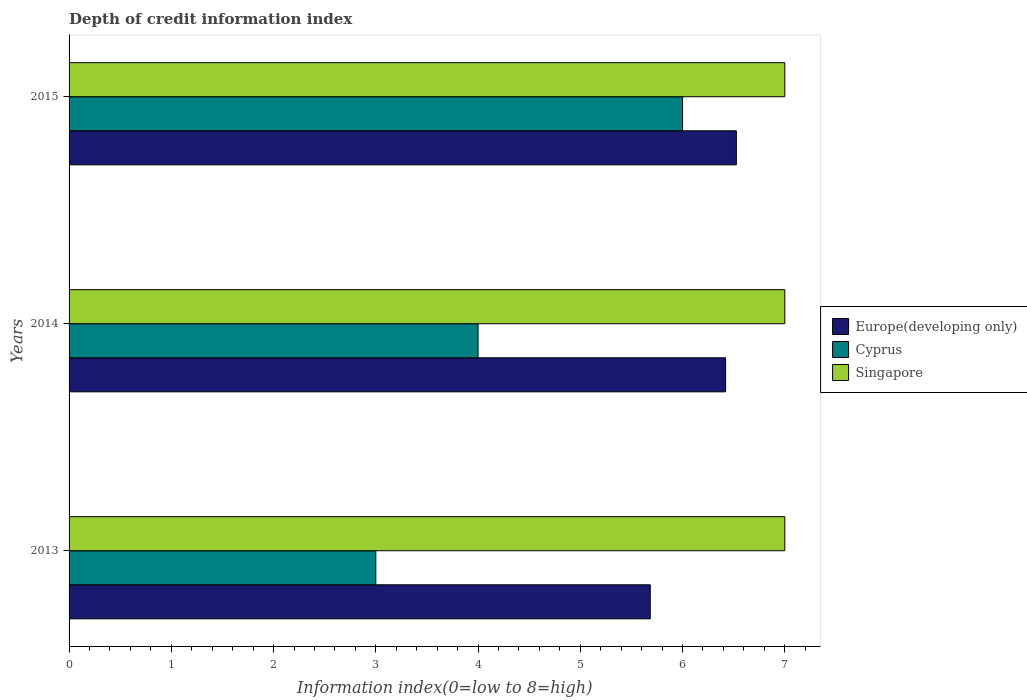How many different coloured bars are there?
Your answer should be compact. 3. Are the number of bars per tick equal to the number of legend labels?
Your response must be concise. Yes. How many bars are there on the 2nd tick from the bottom?
Your response must be concise. 3. What is the label of the 2nd group of bars from the top?
Ensure brevity in your answer.  2014. What is the information index in Cyprus in 2014?
Make the answer very short. 4. Across all years, what is the maximum information index in Cyprus?
Ensure brevity in your answer.  6. Across all years, what is the minimum information index in Europe(developing only)?
Offer a terse response. 5.68. In which year was the information index in Europe(developing only) maximum?
Offer a very short reply. 2015. In which year was the information index in Singapore minimum?
Make the answer very short. 2013. What is the total information index in Singapore in the graph?
Offer a terse response. 21. What is the difference between the information index in Europe(developing only) in 2014 and that in 2015?
Ensure brevity in your answer.  -0.11. What is the difference between the information index in Cyprus in 2014 and the information index in Europe(developing only) in 2013?
Ensure brevity in your answer.  -1.68. In the year 2015, what is the difference between the information index in Cyprus and information index in Europe(developing only)?
Ensure brevity in your answer.  -0.53. What is the ratio of the information index in Europe(developing only) in 2014 to that in 2015?
Your response must be concise. 0.98. What is the difference between the highest and the second highest information index in Europe(developing only)?
Your answer should be very brief. 0.11. What is the difference between the highest and the lowest information index in Europe(developing only)?
Provide a short and direct response. 0.84. What does the 3rd bar from the top in 2015 represents?
Provide a succinct answer. Europe(developing only). What does the 2nd bar from the bottom in 2015 represents?
Give a very brief answer. Cyprus. How many bars are there?
Provide a succinct answer. 9. Are all the bars in the graph horizontal?
Your answer should be very brief. Yes. Does the graph contain any zero values?
Provide a succinct answer. No. Does the graph contain grids?
Your answer should be very brief. No. How are the legend labels stacked?
Your answer should be very brief. Vertical. What is the title of the graph?
Offer a very short reply. Depth of credit information index. Does "Guinea" appear as one of the legend labels in the graph?
Your response must be concise. No. What is the label or title of the X-axis?
Your response must be concise. Information index(0=low to 8=high). What is the label or title of the Y-axis?
Provide a succinct answer. Years. What is the Information index(0=low to 8=high) in Europe(developing only) in 2013?
Offer a terse response. 5.68. What is the Information index(0=low to 8=high) in Singapore in 2013?
Give a very brief answer. 7. What is the Information index(0=low to 8=high) of Europe(developing only) in 2014?
Ensure brevity in your answer.  6.42. What is the Information index(0=low to 8=high) in Cyprus in 2014?
Offer a terse response. 4. What is the Information index(0=low to 8=high) of Europe(developing only) in 2015?
Your answer should be compact. 6.53. What is the Information index(0=low to 8=high) in Singapore in 2015?
Your answer should be compact. 7. Across all years, what is the maximum Information index(0=low to 8=high) of Europe(developing only)?
Offer a very short reply. 6.53. Across all years, what is the minimum Information index(0=low to 8=high) in Europe(developing only)?
Provide a succinct answer. 5.68. What is the total Information index(0=low to 8=high) of Europe(developing only) in the graph?
Give a very brief answer. 18.63. What is the total Information index(0=low to 8=high) in Singapore in the graph?
Ensure brevity in your answer.  21. What is the difference between the Information index(0=low to 8=high) in Europe(developing only) in 2013 and that in 2014?
Your answer should be very brief. -0.74. What is the difference between the Information index(0=low to 8=high) of Cyprus in 2013 and that in 2014?
Your answer should be very brief. -1. What is the difference between the Information index(0=low to 8=high) of Europe(developing only) in 2013 and that in 2015?
Your answer should be compact. -0.84. What is the difference between the Information index(0=low to 8=high) of Cyprus in 2013 and that in 2015?
Offer a terse response. -3. What is the difference between the Information index(0=low to 8=high) of Europe(developing only) in 2014 and that in 2015?
Provide a succinct answer. -0.11. What is the difference between the Information index(0=low to 8=high) of Cyprus in 2014 and that in 2015?
Keep it short and to the point. -2. What is the difference between the Information index(0=low to 8=high) in Europe(developing only) in 2013 and the Information index(0=low to 8=high) in Cyprus in 2014?
Your response must be concise. 1.68. What is the difference between the Information index(0=low to 8=high) in Europe(developing only) in 2013 and the Information index(0=low to 8=high) in Singapore in 2014?
Your response must be concise. -1.32. What is the difference between the Information index(0=low to 8=high) of Europe(developing only) in 2013 and the Information index(0=low to 8=high) of Cyprus in 2015?
Give a very brief answer. -0.32. What is the difference between the Information index(0=low to 8=high) of Europe(developing only) in 2013 and the Information index(0=low to 8=high) of Singapore in 2015?
Keep it short and to the point. -1.32. What is the difference between the Information index(0=low to 8=high) in Cyprus in 2013 and the Information index(0=low to 8=high) in Singapore in 2015?
Provide a succinct answer. -4. What is the difference between the Information index(0=low to 8=high) in Europe(developing only) in 2014 and the Information index(0=low to 8=high) in Cyprus in 2015?
Offer a very short reply. 0.42. What is the difference between the Information index(0=low to 8=high) in Europe(developing only) in 2014 and the Information index(0=low to 8=high) in Singapore in 2015?
Provide a succinct answer. -0.58. What is the average Information index(0=low to 8=high) of Europe(developing only) per year?
Your response must be concise. 6.21. What is the average Information index(0=low to 8=high) of Cyprus per year?
Offer a very short reply. 4.33. What is the average Information index(0=low to 8=high) of Singapore per year?
Provide a short and direct response. 7. In the year 2013, what is the difference between the Information index(0=low to 8=high) in Europe(developing only) and Information index(0=low to 8=high) in Cyprus?
Your answer should be very brief. 2.68. In the year 2013, what is the difference between the Information index(0=low to 8=high) of Europe(developing only) and Information index(0=low to 8=high) of Singapore?
Provide a short and direct response. -1.32. In the year 2013, what is the difference between the Information index(0=low to 8=high) in Cyprus and Information index(0=low to 8=high) in Singapore?
Keep it short and to the point. -4. In the year 2014, what is the difference between the Information index(0=low to 8=high) in Europe(developing only) and Information index(0=low to 8=high) in Cyprus?
Your answer should be compact. 2.42. In the year 2014, what is the difference between the Information index(0=low to 8=high) of Europe(developing only) and Information index(0=low to 8=high) of Singapore?
Provide a short and direct response. -0.58. In the year 2014, what is the difference between the Information index(0=low to 8=high) in Cyprus and Information index(0=low to 8=high) in Singapore?
Provide a short and direct response. -3. In the year 2015, what is the difference between the Information index(0=low to 8=high) of Europe(developing only) and Information index(0=low to 8=high) of Cyprus?
Provide a short and direct response. 0.53. In the year 2015, what is the difference between the Information index(0=low to 8=high) of Europe(developing only) and Information index(0=low to 8=high) of Singapore?
Make the answer very short. -0.47. In the year 2015, what is the difference between the Information index(0=low to 8=high) in Cyprus and Information index(0=low to 8=high) in Singapore?
Your response must be concise. -1. What is the ratio of the Information index(0=low to 8=high) in Europe(developing only) in 2013 to that in 2014?
Ensure brevity in your answer.  0.89. What is the ratio of the Information index(0=low to 8=high) in Cyprus in 2013 to that in 2014?
Offer a very short reply. 0.75. What is the ratio of the Information index(0=low to 8=high) in Singapore in 2013 to that in 2014?
Your response must be concise. 1. What is the ratio of the Information index(0=low to 8=high) of Europe(developing only) in 2013 to that in 2015?
Ensure brevity in your answer.  0.87. What is the ratio of the Information index(0=low to 8=high) in Singapore in 2013 to that in 2015?
Offer a very short reply. 1. What is the ratio of the Information index(0=low to 8=high) in Europe(developing only) in 2014 to that in 2015?
Your answer should be very brief. 0.98. What is the ratio of the Information index(0=low to 8=high) of Cyprus in 2014 to that in 2015?
Your answer should be very brief. 0.67. What is the ratio of the Information index(0=low to 8=high) in Singapore in 2014 to that in 2015?
Keep it short and to the point. 1. What is the difference between the highest and the second highest Information index(0=low to 8=high) in Europe(developing only)?
Make the answer very short. 0.11. What is the difference between the highest and the second highest Information index(0=low to 8=high) in Cyprus?
Offer a very short reply. 2. What is the difference between the highest and the second highest Information index(0=low to 8=high) in Singapore?
Ensure brevity in your answer.  0. What is the difference between the highest and the lowest Information index(0=low to 8=high) in Europe(developing only)?
Provide a short and direct response. 0.84. 